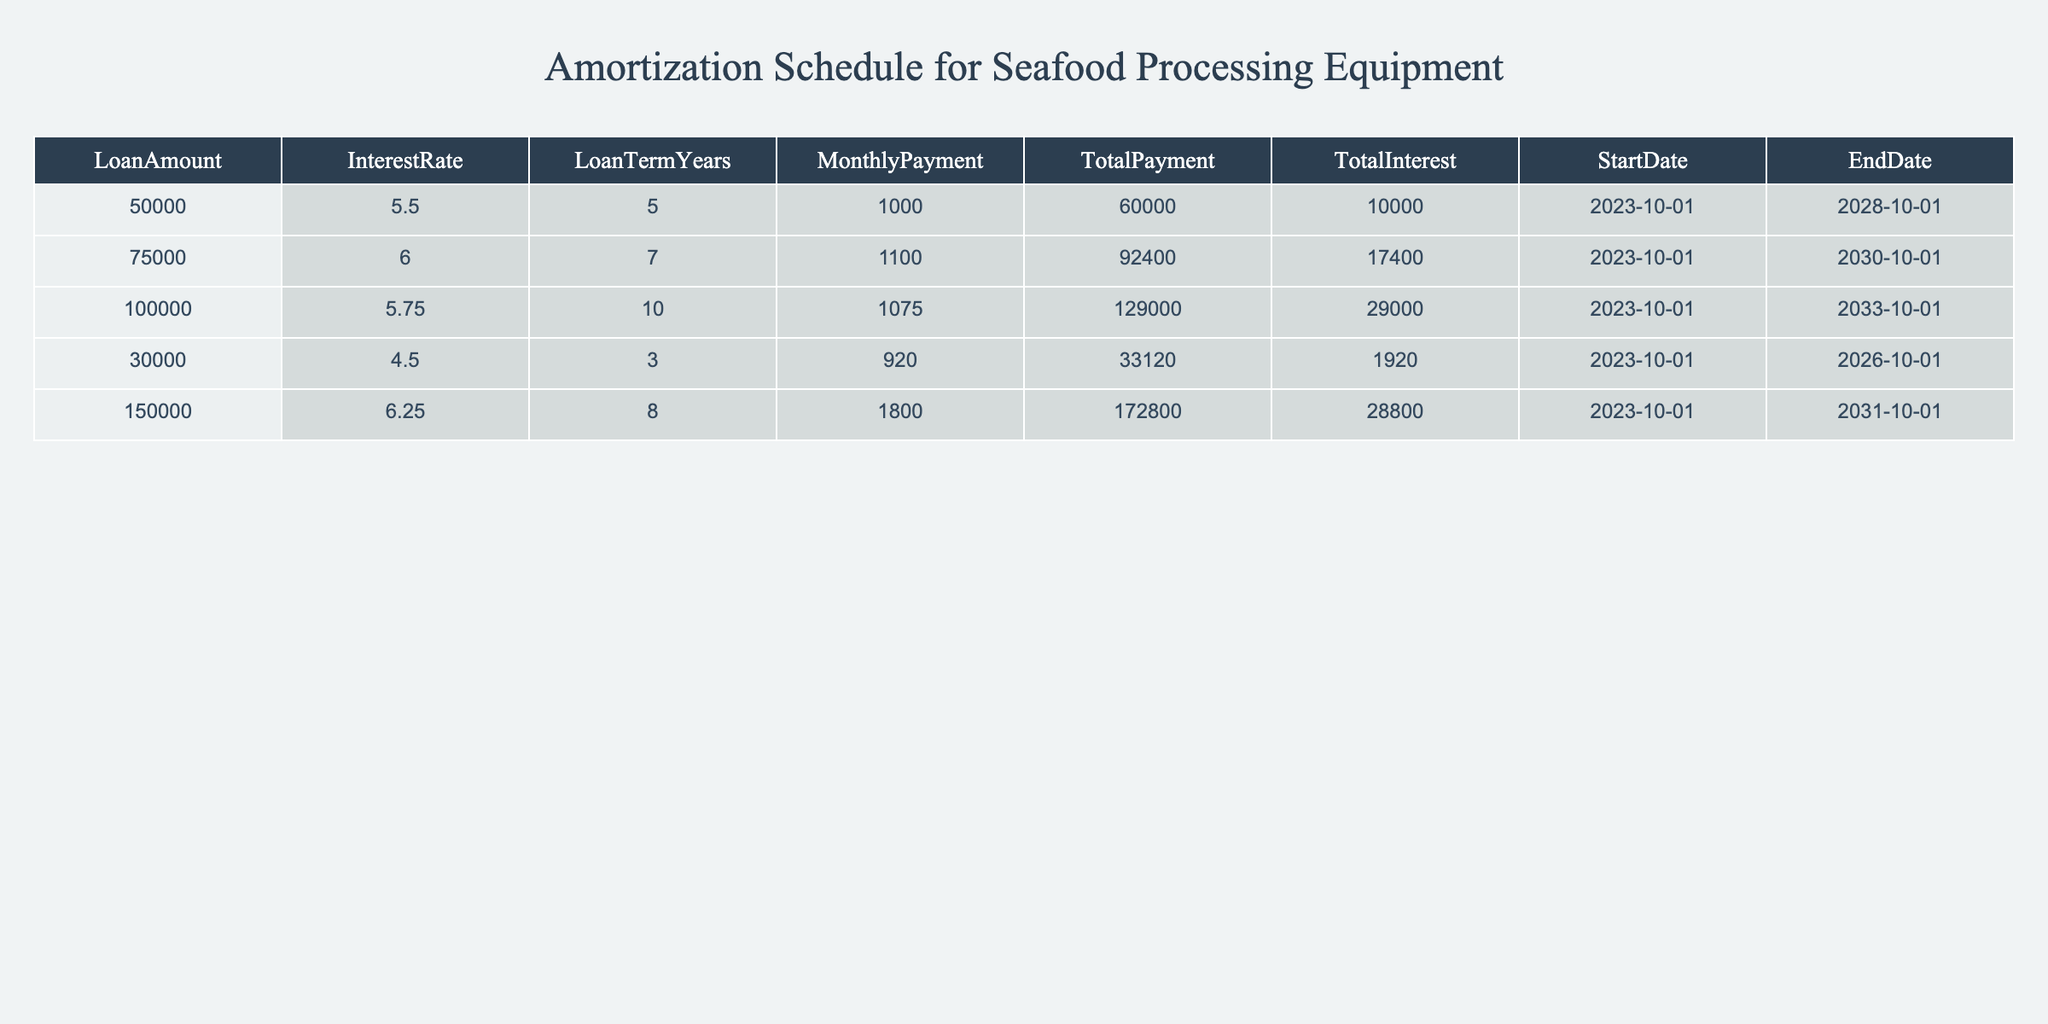What is the monthly payment for the loan amount of $150,000? The monthly payment is directly listed under the "MonthlyPayment" column for the $150,000 loan. It shows $1800.00.
Answer: 1800.00 How much total interest will be paid over the term of the $75,000 loan? The total interest for the $75,000 loan is listed in the "TotalInterest" column. It shows $17,400.00.
Answer: 17400.00 What is the duration of the loan for the $30,000 amount in years? The loan term for the $30,000 loan is indicated in the "LoanTermYears" column, which shows 3 years.
Answer: 3 Is the total payment for the $100,000 loan greater than $120,000? The total payment for the $100,000 loan is $129,000.00, which is greater than $120,000. Therefore, the statement is true.
Answer: Yes What is the total payment difference between the $50,000 loan and the $150,000 loan? The total payment for the $50,000 loan is $60,000.00 and for the $150,000 loan is $172,800.00. The difference can be calculated as $172,800 - $60,000 = $112,800.
Answer: 112800.00 How much total payment is made for loans with terms shorter than 6 years? To find this, we look at the loans with 5 years ($60,000), 3 years ($33,120), and 5 years ($92,400). Adding these gives $60,000 + $33,120 + $92,400 = $185,520.
Answer: 185520.00 What is the average interest paid across all listed loans? The total interest paid across all loans is $10,000 + $17,400 + $29,000 + $1,920 + $28,800 = $87,120. There are 5 loans, so we compute the average: $87,120 / 5 = $17,424.00.
Answer: 17424.00 Which loan has the highest interest rate, and what is the rate? The loan with the highest interest rate is for $150,000, with an interest rate of 6.25%.
Answer: 6.25% 